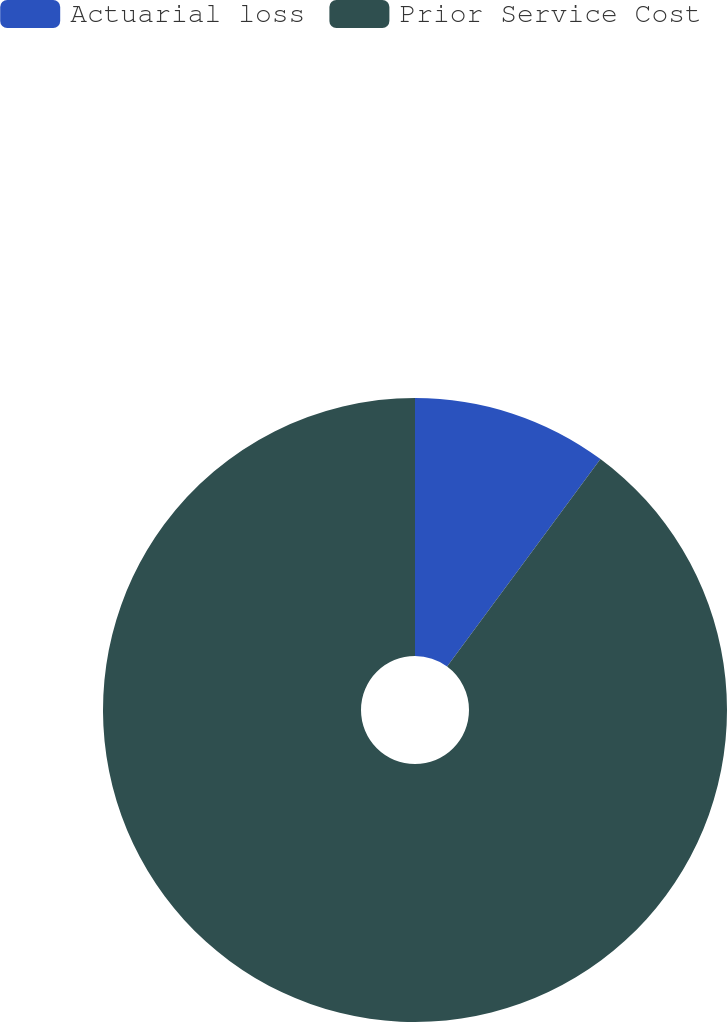Convert chart to OTSL. <chart><loc_0><loc_0><loc_500><loc_500><pie_chart><fcel>Actuarial loss<fcel>Prior Service Cost<nl><fcel>10.13%<fcel>89.87%<nl></chart> 